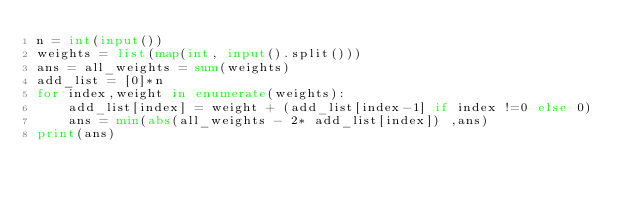<code> <loc_0><loc_0><loc_500><loc_500><_Python_>n = int(input())
weights = list(map(int, input().split()))
ans = all_weights = sum(weights)
add_list = [0]*n
for index,weight in enumerate(weights):
    add_list[index] = weight + (add_list[index-1] if index !=0 else 0)
    ans = min(abs(all_weights - 2* add_list[index]) ,ans)
print(ans)</code> 